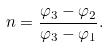Convert formula to latex. <formula><loc_0><loc_0><loc_500><loc_500>n = \frac { \varphi _ { 3 } - \varphi _ { 2 } } { \varphi _ { 3 } - \varphi _ { 1 } } .</formula> 